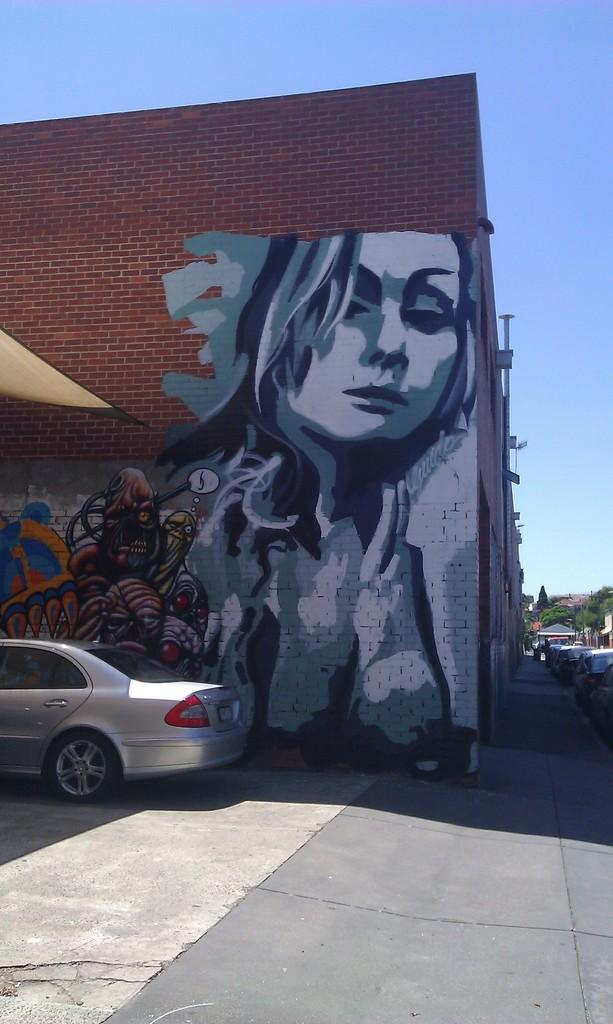What is parked on the road in the image? There is a car parked on the road in the image. What can be seen on the building in the image? There is a painting on the building in the image. What is visible in the background of the image? There is a mountain in the background of the image. What type of vegetation is present on the mountain? There are many trees visible on the mountain. Where are the tomatoes growing in the image? There are no tomatoes present in the image. What color is the hen's tail in the image? There is no hen present in the image. 